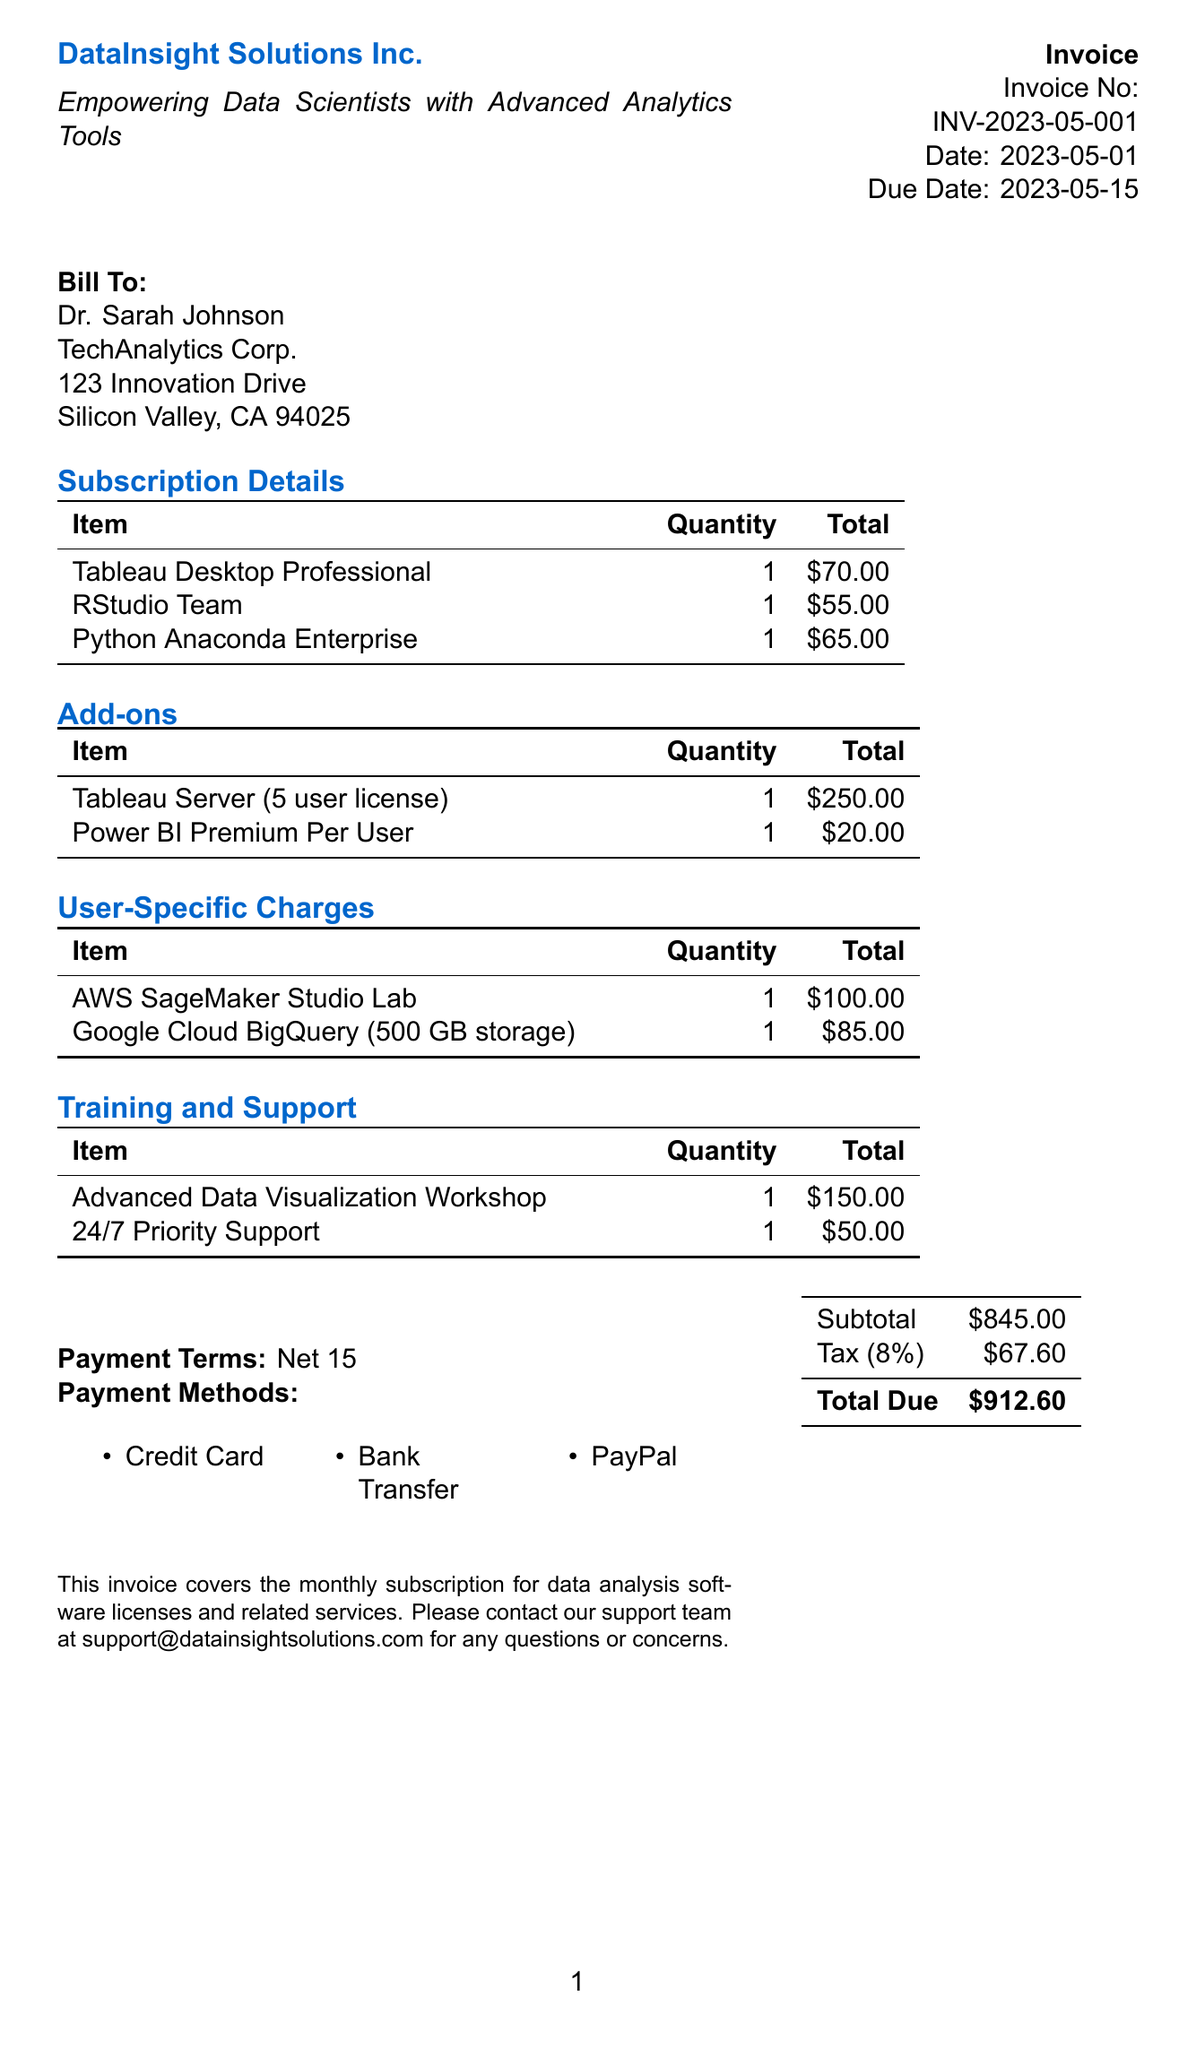What is the invoice number? The invoice number is a unique identifier for this document, specifically labeled as INV-2023-05-001.
Answer: INV-2023-05-001 Who is the client? The client is the individual or entity to whom the invoice is addressed; in this case, it is Dr. Sarah Johnson.
Answer: Dr. Sarah Johnson What is the total due amount? The total due amount is the final sum that needs to be paid as indicated at the bottom of the invoice, which amounts to $912.60.
Answer: $912.60 What items are included in the subscription details? The subscription details include specific software licenses for data analysis; namely, Tableau Desktop Professional, RStudio Team, and Python Anaconda Enterprise.
Answer: Tableau Desktop Professional, RStudio Team, Python Anaconda Enterprise What is the tax rate applied to the invoice? The tax rate is the percentage used to calculate the tax amount on the invoice; it is stated as 8%.
Answer: 8% How many user-specific charges are listed? The user-specific charges section highlights costs associated with particular services, specifically stating two charges: AWS SageMaker Studio Lab and Google Cloud BigQuery.
Answer: 2 What type of training is offered according to the invoice? The invoice specifies a training-related charge for an 'Advanced Data Visualization Workshop,' indicating the nature of the training offered.
Answer: Advanced Data Visualization Workshop When is the payment due? The due date indicates when the total payment is expected, which is noted as May 15, 2023.
Answer: May 15, 2023 What payment methods are accepted? The invoice lists several payment options for settling the amount due, which include Credit Card, Bank Transfer, and PayPal.
Answer: Credit Card, Bank Transfer, PayPal 